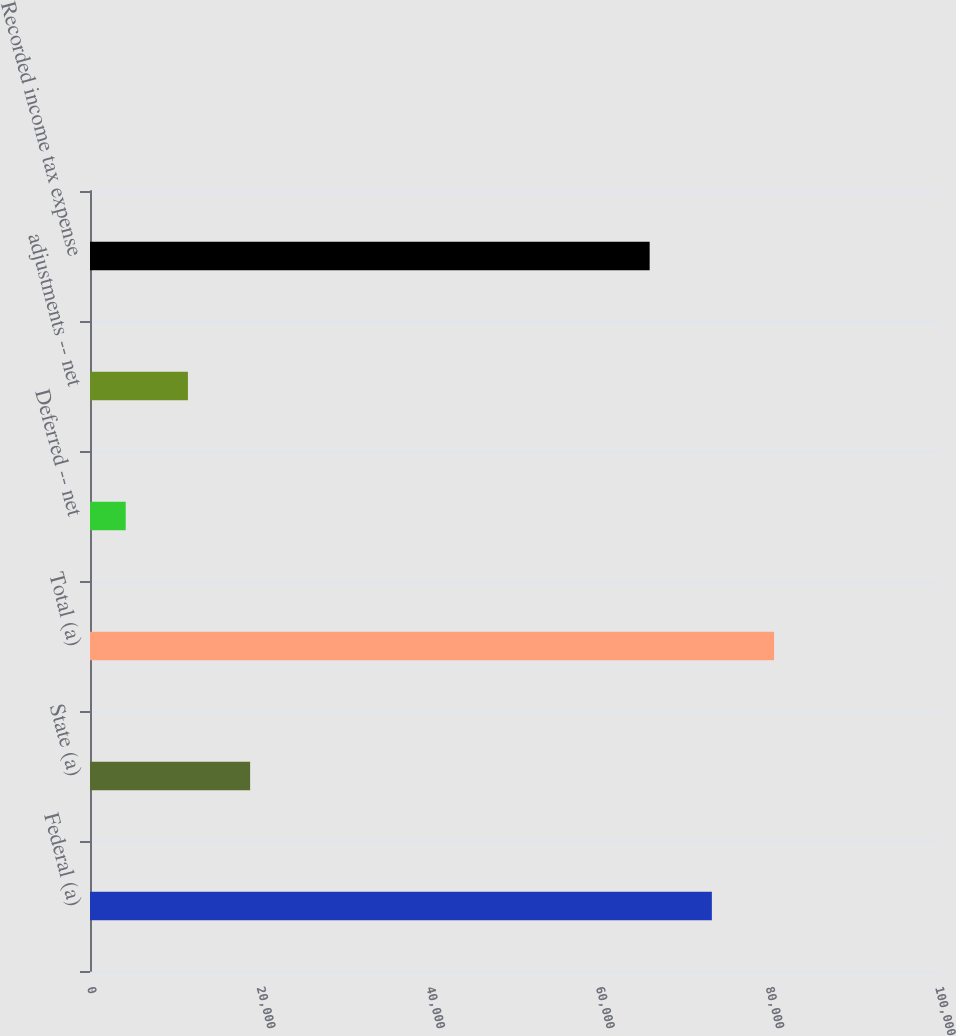<chart> <loc_0><loc_0><loc_500><loc_500><bar_chart><fcel>Federal (a)<fcel>State (a)<fcel>Total (a)<fcel>Deferred -- net<fcel>adjustments -- net<fcel>Recorded income tax expense<nl><fcel>73333.2<fcel>18882.4<fcel>80669.4<fcel>4210<fcel>11546.2<fcel>65997<nl></chart> 